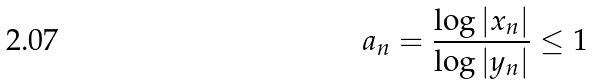Convert formula to latex. <formula><loc_0><loc_0><loc_500><loc_500>a _ { n } = \frac { \log | x _ { n } | } { \log | y _ { n } | } \leq 1</formula> 